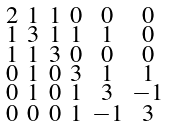Convert formula to latex. <formula><loc_0><loc_0><loc_500><loc_500>\begin{smallmatrix} 2 & 1 & 1 & 0 & 0 & 0 \\ 1 & 3 & 1 & 1 & 1 & 0 \\ 1 & 1 & 3 & 0 & 0 & 0 \\ 0 & 1 & 0 & 3 & 1 & 1 \\ 0 & 1 & 0 & 1 & 3 & - 1 \\ 0 & 0 & 0 & 1 & - 1 & 3 \end{smallmatrix}</formula> 